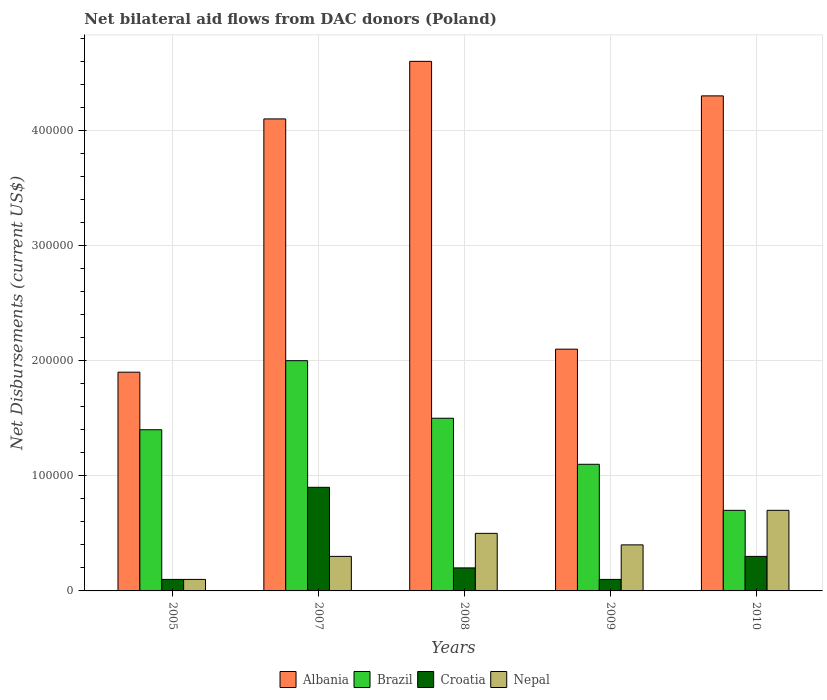Across all years, what is the maximum net bilateral aid flows in Albania?
Your response must be concise. 4.60e+05. What is the total net bilateral aid flows in Brazil in the graph?
Ensure brevity in your answer.  6.70e+05. What is the difference between the net bilateral aid flows in Albania in 2005 and that in 2009?
Offer a terse response. -2.00e+04. What is the difference between the net bilateral aid flows in Albania in 2008 and the net bilateral aid flows in Croatia in 2007?
Give a very brief answer. 3.70e+05. In how many years, is the net bilateral aid flows in Brazil greater than 240000 US$?
Your response must be concise. 0. What is the ratio of the net bilateral aid flows in Brazil in 2007 to that in 2009?
Your answer should be compact. 1.82. Is the difference between the net bilateral aid flows in Nepal in 2009 and 2010 greater than the difference between the net bilateral aid flows in Albania in 2009 and 2010?
Provide a succinct answer. Yes. Is the sum of the net bilateral aid flows in Albania in 2007 and 2010 greater than the maximum net bilateral aid flows in Nepal across all years?
Give a very brief answer. Yes. What does the 3rd bar from the left in 2007 represents?
Your answer should be very brief. Croatia. What does the 4th bar from the right in 2007 represents?
Ensure brevity in your answer.  Albania. Is it the case that in every year, the sum of the net bilateral aid flows in Albania and net bilateral aid flows in Nepal is greater than the net bilateral aid flows in Brazil?
Provide a succinct answer. Yes. How many years are there in the graph?
Your answer should be very brief. 5. Does the graph contain any zero values?
Ensure brevity in your answer.  No. Does the graph contain grids?
Offer a very short reply. Yes. Where does the legend appear in the graph?
Your answer should be compact. Bottom center. What is the title of the graph?
Ensure brevity in your answer.  Net bilateral aid flows from DAC donors (Poland). What is the label or title of the X-axis?
Provide a short and direct response. Years. What is the label or title of the Y-axis?
Provide a short and direct response. Net Disbursements (current US$). What is the Net Disbursements (current US$) of Brazil in 2005?
Ensure brevity in your answer.  1.40e+05. What is the Net Disbursements (current US$) of Nepal in 2005?
Keep it short and to the point. 10000. What is the Net Disbursements (current US$) of Albania in 2007?
Your answer should be very brief. 4.10e+05. What is the Net Disbursements (current US$) in Brazil in 2008?
Your response must be concise. 1.50e+05. What is the Net Disbursements (current US$) of Croatia in 2008?
Offer a very short reply. 2.00e+04. What is the Net Disbursements (current US$) of Albania in 2009?
Make the answer very short. 2.10e+05. What is the Net Disbursements (current US$) of Nepal in 2009?
Give a very brief answer. 4.00e+04. Across all years, what is the maximum Net Disbursements (current US$) in Albania?
Keep it short and to the point. 4.60e+05. Across all years, what is the maximum Net Disbursements (current US$) of Brazil?
Offer a terse response. 2.00e+05. Across all years, what is the maximum Net Disbursements (current US$) of Nepal?
Ensure brevity in your answer.  7.00e+04. Across all years, what is the minimum Net Disbursements (current US$) in Albania?
Offer a terse response. 1.90e+05. Across all years, what is the minimum Net Disbursements (current US$) in Croatia?
Keep it short and to the point. 10000. Across all years, what is the minimum Net Disbursements (current US$) of Nepal?
Provide a succinct answer. 10000. What is the total Net Disbursements (current US$) of Albania in the graph?
Your answer should be very brief. 1.70e+06. What is the total Net Disbursements (current US$) in Brazil in the graph?
Your answer should be very brief. 6.70e+05. What is the total Net Disbursements (current US$) of Croatia in the graph?
Give a very brief answer. 1.60e+05. What is the total Net Disbursements (current US$) of Nepal in the graph?
Offer a very short reply. 2.00e+05. What is the difference between the Net Disbursements (current US$) in Brazil in 2005 and that in 2007?
Provide a succinct answer. -6.00e+04. What is the difference between the Net Disbursements (current US$) in Albania in 2005 and that in 2008?
Provide a short and direct response. -2.70e+05. What is the difference between the Net Disbursements (current US$) of Brazil in 2005 and that in 2009?
Offer a very short reply. 3.00e+04. What is the difference between the Net Disbursements (current US$) in Croatia in 2005 and that in 2010?
Make the answer very short. -2.00e+04. What is the difference between the Net Disbursements (current US$) of Nepal in 2005 and that in 2010?
Keep it short and to the point. -6.00e+04. What is the difference between the Net Disbursements (current US$) of Albania in 2007 and that in 2008?
Ensure brevity in your answer.  -5.00e+04. What is the difference between the Net Disbursements (current US$) in Albania in 2007 and that in 2009?
Provide a short and direct response. 2.00e+05. What is the difference between the Net Disbursements (current US$) of Croatia in 2007 and that in 2009?
Provide a short and direct response. 8.00e+04. What is the difference between the Net Disbursements (current US$) in Croatia in 2007 and that in 2010?
Provide a succinct answer. 6.00e+04. What is the difference between the Net Disbursements (current US$) of Albania in 2008 and that in 2009?
Your answer should be compact. 2.50e+05. What is the difference between the Net Disbursements (current US$) of Brazil in 2008 and that in 2009?
Ensure brevity in your answer.  4.00e+04. What is the difference between the Net Disbursements (current US$) in Nepal in 2008 and that in 2009?
Offer a very short reply. 10000. What is the difference between the Net Disbursements (current US$) of Brazil in 2008 and that in 2010?
Ensure brevity in your answer.  8.00e+04. What is the difference between the Net Disbursements (current US$) in Croatia in 2008 and that in 2010?
Your response must be concise. -10000. What is the difference between the Net Disbursements (current US$) of Nepal in 2008 and that in 2010?
Keep it short and to the point. -2.00e+04. What is the difference between the Net Disbursements (current US$) in Albania in 2009 and that in 2010?
Provide a short and direct response. -2.20e+05. What is the difference between the Net Disbursements (current US$) of Croatia in 2009 and that in 2010?
Keep it short and to the point. -2.00e+04. What is the difference between the Net Disbursements (current US$) in Nepal in 2009 and that in 2010?
Offer a very short reply. -3.00e+04. What is the difference between the Net Disbursements (current US$) of Albania in 2005 and the Net Disbursements (current US$) of Nepal in 2007?
Your answer should be very brief. 1.60e+05. What is the difference between the Net Disbursements (current US$) of Brazil in 2005 and the Net Disbursements (current US$) of Croatia in 2007?
Keep it short and to the point. 5.00e+04. What is the difference between the Net Disbursements (current US$) of Croatia in 2005 and the Net Disbursements (current US$) of Nepal in 2007?
Offer a very short reply. -2.00e+04. What is the difference between the Net Disbursements (current US$) of Albania in 2005 and the Net Disbursements (current US$) of Croatia in 2008?
Provide a short and direct response. 1.70e+05. What is the difference between the Net Disbursements (current US$) of Albania in 2005 and the Net Disbursements (current US$) of Brazil in 2009?
Provide a short and direct response. 8.00e+04. What is the difference between the Net Disbursements (current US$) of Albania in 2005 and the Net Disbursements (current US$) of Croatia in 2009?
Provide a succinct answer. 1.80e+05. What is the difference between the Net Disbursements (current US$) of Albania in 2005 and the Net Disbursements (current US$) of Nepal in 2009?
Your answer should be compact. 1.50e+05. What is the difference between the Net Disbursements (current US$) of Croatia in 2005 and the Net Disbursements (current US$) of Nepal in 2009?
Provide a short and direct response. -3.00e+04. What is the difference between the Net Disbursements (current US$) in Albania in 2005 and the Net Disbursements (current US$) in Nepal in 2010?
Your response must be concise. 1.20e+05. What is the difference between the Net Disbursements (current US$) of Brazil in 2005 and the Net Disbursements (current US$) of Croatia in 2010?
Give a very brief answer. 1.10e+05. What is the difference between the Net Disbursements (current US$) of Brazil in 2005 and the Net Disbursements (current US$) of Nepal in 2010?
Offer a terse response. 7.00e+04. What is the difference between the Net Disbursements (current US$) of Albania in 2007 and the Net Disbursements (current US$) of Croatia in 2008?
Ensure brevity in your answer.  3.90e+05. What is the difference between the Net Disbursements (current US$) of Albania in 2007 and the Net Disbursements (current US$) of Nepal in 2008?
Ensure brevity in your answer.  3.60e+05. What is the difference between the Net Disbursements (current US$) of Brazil in 2007 and the Net Disbursements (current US$) of Croatia in 2008?
Ensure brevity in your answer.  1.80e+05. What is the difference between the Net Disbursements (current US$) in Brazil in 2007 and the Net Disbursements (current US$) in Nepal in 2008?
Provide a succinct answer. 1.50e+05. What is the difference between the Net Disbursements (current US$) of Albania in 2007 and the Net Disbursements (current US$) of Brazil in 2009?
Make the answer very short. 3.00e+05. What is the difference between the Net Disbursements (current US$) of Albania in 2007 and the Net Disbursements (current US$) of Nepal in 2009?
Provide a succinct answer. 3.70e+05. What is the difference between the Net Disbursements (current US$) of Brazil in 2007 and the Net Disbursements (current US$) of Croatia in 2009?
Provide a succinct answer. 1.90e+05. What is the difference between the Net Disbursements (current US$) in Brazil in 2007 and the Net Disbursements (current US$) in Nepal in 2009?
Your response must be concise. 1.60e+05. What is the difference between the Net Disbursements (current US$) in Croatia in 2007 and the Net Disbursements (current US$) in Nepal in 2009?
Keep it short and to the point. 5.00e+04. What is the difference between the Net Disbursements (current US$) in Albania in 2007 and the Net Disbursements (current US$) in Brazil in 2010?
Make the answer very short. 3.40e+05. What is the difference between the Net Disbursements (current US$) of Albania in 2007 and the Net Disbursements (current US$) of Nepal in 2010?
Keep it short and to the point. 3.40e+05. What is the difference between the Net Disbursements (current US$) of Brazil in 2007 and the Net Disbursements (current US$) of Croatia in 2010?
Your response must be concise. 1.70e+05. What is the difference between the Net Disbursements (current US$) of Brazil in 2007 and the Net Disbursements (current US$) of Nepal in 2010?
Offer a terse response. 1.30e+05. What is the difference between the Net Disbursements (current US$) in Croatia in 2007 and the Net Disbursements (current US$) in Nepal in 2010?
Provide a short and direct response. 2.00e+04. What is the difference between the Net Disbursements (current US$) in Albania in 2008 and the Net Disbursements (current US$) in Croatia in 2009?
Provide a short and direct response. 4.50e+05. What is the difference between the Net Disbursements (current US$) in Albania in 2008 and the Net Disbursements (current US$) in Nepal in 2009?
Offer a terse response. 4.20e+05. What is the difference between the Net Disbursements (current US$) in Brazil in 2008 and the Net Disbursements (current US$) in Croatia in 2009?
Your response must be concise. 1.40e+05. What is the difference between the Net Disbursements (current US$) of Brazil in 2008 and the Net Disbursements (current US$) of Nepal in 2009?
Offer a very short reply. 1.10e+05. What is the difference between the Net Disbursements (current US$) in Croatia in 2008 and the Net Disbursements (current US$) in Nepal in 2009?
Give a very brief answer. -2.00e+04. What is the difference between the Net Disbursements (current US$) in Albania in 2008 and the Net Disbursements (current US$) in Brazil in 2010?
Give a very brief answer. 3.90e+05. What is the difference between the Net Disbursements (current US$) in Albania in 2008 and the Net Disbursements (current US$) in Croatia in 2010?
Your response must be concise. 4.30e+05. What is the difference between the Net Disbursements (current US$) in Albania in 2008 and the Net Disbursements (current US$) in Nepal in 2010?
Make the answer very short. 3.90e+05. What is the difference between the Net Disbursements (current US$) in Brazil in 2008 and the Net Disbursements (current US$) in Croatia in 2010?
Offer a terse response. 1.20e+05. What is the difference between the Net Disbursements (current US$) in Brazil in 2008 and the Net Disbursements (current US$) in Nepal in 2010?
Offer a terse response. 8.00e+04. What is the difference between the Net Disbursements (current US$) in Albania in 2009 and the Net Disbursements (current US$) in Croatia in 2010?
Offer a very short reply. 1.80e+05. What is the difference between the Net Disbursements (current US$) of Albania in 2009 and the Net Disbursements (current US$) of Nepal in 2010?
Give a very brief answer. 1.40e+05. What is the difference between the Net Disbursements (current US$) in Brazil in 2009 and the Net Disbursements (current US$) in Croatia in 2010?
Keep it short and to the point. 8.00e+04. What is the difference between the Net Disbursements (current US$) in Brazil in 2009 and the Net Disbursements (current US$) in Nepal in 2010?
Offer a terse response. 4.00e+04. What is the difference between the Net Disbursements (current US$) in Croatia in 2009 and the Net Disbursements (current US$) in Nepal in 2010?
Offer a terse response. -6.00e+04. What is the average Net Disbursements (current US$) in Albania per year?
Offer a terse response. 3.40e+05. What is the average Net Disbursements (current US$) in Brazil per year?
Your response must be concise. 1.34e+05. What is the average Net Disbursements (current US$) in Croatia per year?
Offer a very short reply. 3.20e+04. What is the average Net Disbursements (current US$) in Nepal per year?
Keep it short and to the point. 4.00e+04. In the year 2005, what is the difference between the Net Disbursements (current US$) in Albania and Net Disbursements (current US$) in Croatia?
Provide a succinct answer. 1.80e+05. In the year 2005, what is the difference between the Net Disbursements (current US$) in Albania and Net Disbursements (current US$) in Nepal?
Provide a succinct answer. 1.80e+05. In the year 2005, what is the difference between the Net Disbursements (current US$) in Croatia and Net Disbursements (current US$) in Nepal?
Your answer should be very brief. 0. In the year 2007, what is the difference between the Net Disbursements (current US$) in Albania and Net Disbursements (current US$) in Brazil?
Offer a very short reply. 2.10e+05. In the year 2007, what is the difference between the Net Disbursements (current US$) of Brazil and Net Disbursements (current US$) of Croatia?
Your answer should be compact. 1.10e+05. In the year 2007, what is the difference between the Net Disbursements (current US$) in Brazil and Net Disbursements (current US$) in Nepal?
Keep it short and to the point. 1.70e+05. In the year 2007, what is the difference between the Net Disbursements (current US$) in Croatia and Net Disbursements (current US$) in Nepal?
Provide a short and direct response. 6.00e+04. In the year 2008, what is the difference between the Net Disbursements (current US$) in Albania and Net Disbursements (current US$) in Nepal?
Your answer should be compact. 4.10e+05. In the year 2008, what is the difference between the Net Disbursements (current US$) in Brazil and Net Disbursements (current US$) in Nepal?
Offer a terse response. 1.00e+05. In the year 2008, what is the difference between the Net Disbursements (current US$) of Croatia and Net Disbursements (current US$) of Nepal?
Keep it short and to the point. -3.00e+04. In the year 2009, what is the difference between the Net Disbursements (current US$) in Albania and Net Disbursements (current US$) in Brazil?
Your answer should be compact. 1.00e+05. In the year 2009, what is the difference between the Net Disbursements (current US$) of Brazil and Net Disbursements (current US$) of Croatia?
Ensure brevity in your answer.  1.00e+05. In the year 2009, what is the difference between the Net Disbursements (current US$) of Croatia and Net Disbursements (current US$) of Nepal?
Your response must be concise. -3.00e+04. In the year 2010, what is the difference between the Net Disbursements (current US$) in Albania and Net Disbursements (current US$) in Brazil?
Make the answer very short. 3.60e+05. In the year 2010, what is the difference between the Net Disbursements (current US$) of Brazil and Net Disbursements (current US$) of Croatia?
Your response must be concise. 4.00e+04. In the year 2010, what is the difference between the Net Disbursements (current US$) in Croatia and Net Disbursements (current US$) in Nepal?
Provide a short and direct response. -4.00e+04. What is the ratio of the Net Disbursements (current US$) of Albania in 2005 to that in 2007?
Offer a very short reply. 0.46. What is the ratio of the Net Disbursements (current US$) of Croatia in 2005 to that in 2007?
Offer a very short reply. 0.11. What is the ratio of the Net Disbursements (current US$) in Nepal in 2005 to that in 2007?
Make the answer very short. 0.33. What is the ratio of the Net Disbursements (current US$) of Albania in 2005 to that in 2008?
Ensure brevity in your answer.  0.41. What is the ratio of the Net Disbursements (current US$) of Nepal in 2005 to that in 2008?
Your answer should be compact. 0.2. What is the ratio of the Net Disbursements (current US$) of Albania in 2005 to that in 2009?
Provide a short and direct response. 0.9. What is the ratio of the Net Disbursements (current US$) of Brazil in 2005 to that in 2009?
Offer a terse response. 1.27. What is the ratio of the Net Disbursements (current US$) of Croatia in 2005 to that in 2009?
Offer a very short reply. 1. What is the ratio of the Net Disbursements (current US$) of Nepal in 2005 to that in 2009?
Make the answer very short. 0.25. What is the ratio of the Net Disbursements (current US$) of Albania in 2005 to that in 2010?
Offer a terse response. 0.44. What is the ratio of the Net Disbursements (current US$) of Croatia in 2005 to that in 2010?
Your answer should be compact. 0.33. What is the ratio of the Net Disbursements (current US$) in Nepal in 2005 to that in 2010?
Keep it short and to the point. 0.14. What is the ratio of the Net Disbursements (current US$) of Albania in 2007 to that in 2008?
Offer a terse response. 0.89. What is the ratio of the Net Disbursements (current US$) of Brazil in 2007 to that in 2008?
Offer a very short reply. 1.33. What is the ratio of the Net Disbursements (current US$) in Croatia in 2007 to that in 2008?
Provide a succinct answer. 4.5. What is the ratio of the Net Disbursements (current US$) in Albania in 2007 to that in 2009?
Make the answer very short. 1.95. What is the ratio of the Net Disbursements (current US$) of Brazil in 2007 to that in 2009?
Offer a very short reply. 1.82. What is the ratio of the Net Disbursements (current US$) in Croatia in 2007 to that in 2009?
Ensure brevity in your answer.  9. What is the ratio of the Net Disbursements (current US$) in Albania in 2007 to that in 2010?
Offer a very short reply. 0.95. What is the ratio of the Net Disbursements (current US$) in Brazil in 2007 to that in 2010?
Your response must be concise. 2.86. What is the ratio of the Net Disbursements (current US$) in Croatia in 2007 to that in 2010?
Your response must be concise. 3. What is the ratio of the Net Disbursements (current US$) of Nepal in 2007 to that in 2010?
Ensure brevity in your answer.  0.43. What is the ratio of the Net Disbursements (current US$) in Albania in 2008 to that in 2009?
Make the answer very short. 2.19. What is the ratio of the Net Disbursements (current US$) in Brazil in 2008 to that in 2009?
Make the answer very short. 1.36. What is the ratio of the Net Disbursements (current US$) in Croatia in 2008 to that in 2009?
Offer a terse response. 2. What is the ratio of the Net Disbursements (current US$) in Nepal in 2008 to that in 2009?
Provide a succinct answer. 1.25. What is the ratio of the Net Disbursements (current US$) of Albania in 2008 to that in 2010?
Ensure brevity in your answer.  1.07. What is the ratio of the Net Disbursements (current US$) of Brazil in 2008 to that in 2010?
Offer a terse response. 2.14. What is the ratio of the Net Disbursements (current US$) of Croatia in 2008 to that in 2010?
Make the answer very short. 0.67. What is the ratio of the Net Disbursements (current US$) of Albania in 2009 to that in 2010?
Provide a succinct answer. 0.49. What is the ratio of the Net Disbursements (current US$) in Brazil in 2009 to that in 2010?
Your answer should be very brief. 1.57. What is the ratio of the Net Disbursements (current US$) of Nepal in 2009 to that in 2010?
Offer a terse response. 0.57. What is the difference between the highest and the second highest Net Disbursements (current US$) of Croatia?
Your answer should be very brief. 6.00e+04. What is the difference between the highest and the second highest Net Disbursements (current US$) of Nepal?
Your answer should be very brief. 2.00e+04. What is the difference between the highest and the lowest Net Disbursements (current US$) in Brazil?
Make the answer very short. 1.30e+05. What is the difference between the highest and the lowest Net Disbursements (current US$) of Croatia?
Ensure brevity in your answer.  8.00e+04. 